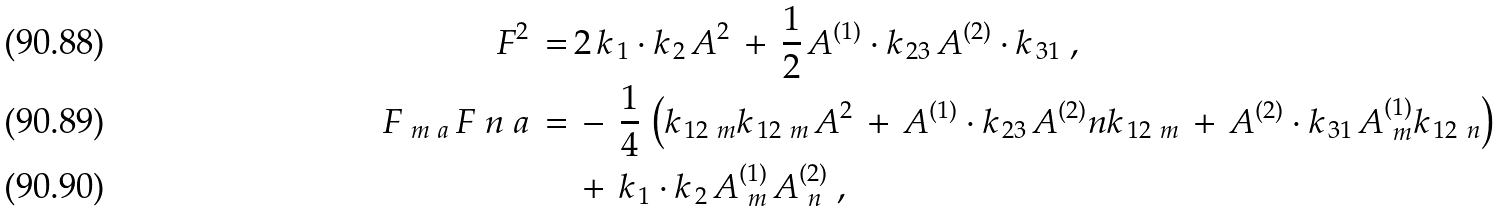Convert formula to latex. <formula><loc_0><loc_0><loc_500><loc_500>F ^ { 2 } \, = \, & 2 \, k _ { \, 1 } \cdot k _ { \, 2 } \, A ^ { 2 } \, + \, \frac { 1 } { 2 } \, A ^ { ( 1 ) } \cdot k _ { \, 2 3 } \, A ^ { ( 2 ) } \cdot k _ { \, 3 1 } \ , \\ F _ { \ m \ a } \, { F _ { \ } n } ^ { \ } a \, = \, & - \, \frac { 1 } { 4 } \, \left ( k _ { \, 1 2 \ m } k _ { \, 1 2 \ m } \, A ^ { 2 } \, + \, A ^ { ( 1 ) } \cdot k _ { \, 2 3 } \, A ^ { ( 2 ) } _ { \ } n k _ { \, 1 2 \ m } \, + \, A ^ { ( 2 ) } \cdot k _ { \, 3 1 } \, A _ { \ m } ^ { ( 1 ) } k _ { \, 1 2 \ n } \right ) \\ & + \, k _ { \, 1 } \cdot k _ { \, 2 } \, A _ { \ m } ^ { ( 1 ) } \, A _ { \ n } ^ { ( 2 ) } \ ,</formula> 